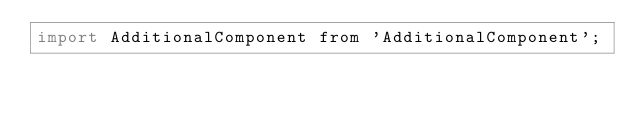<code> <loc_0><loc_0><loc_500><loc_500><_JavaScript_>import AdditionalComponent from 'AdditionalComponent';

</code> 